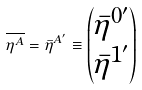Convert formula to latex. <formula><loc_0><loc_0><loc_500><loc_500>\overline { \eta ^ { A } } = \bar { \eta } ^ { A ^ { \prime } } \equiv \begin{pmatrix} \bar { \eta } ^ { 0 ^ { \prime } } \\ \bar { \eta } ^ { 1 ^ { \prime } } \\ \end{pmatrix}</formula> 